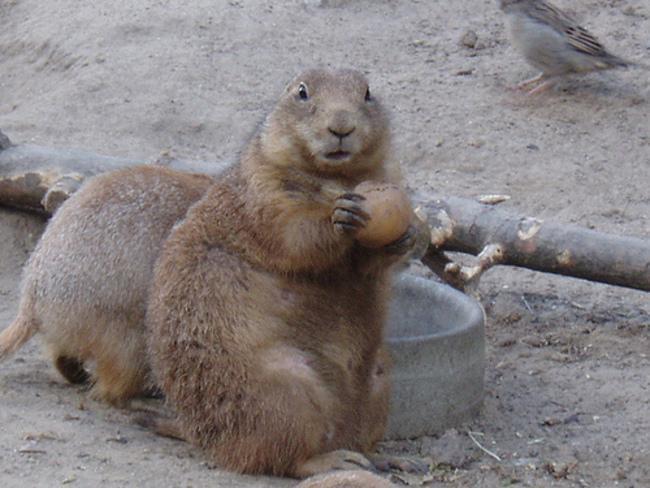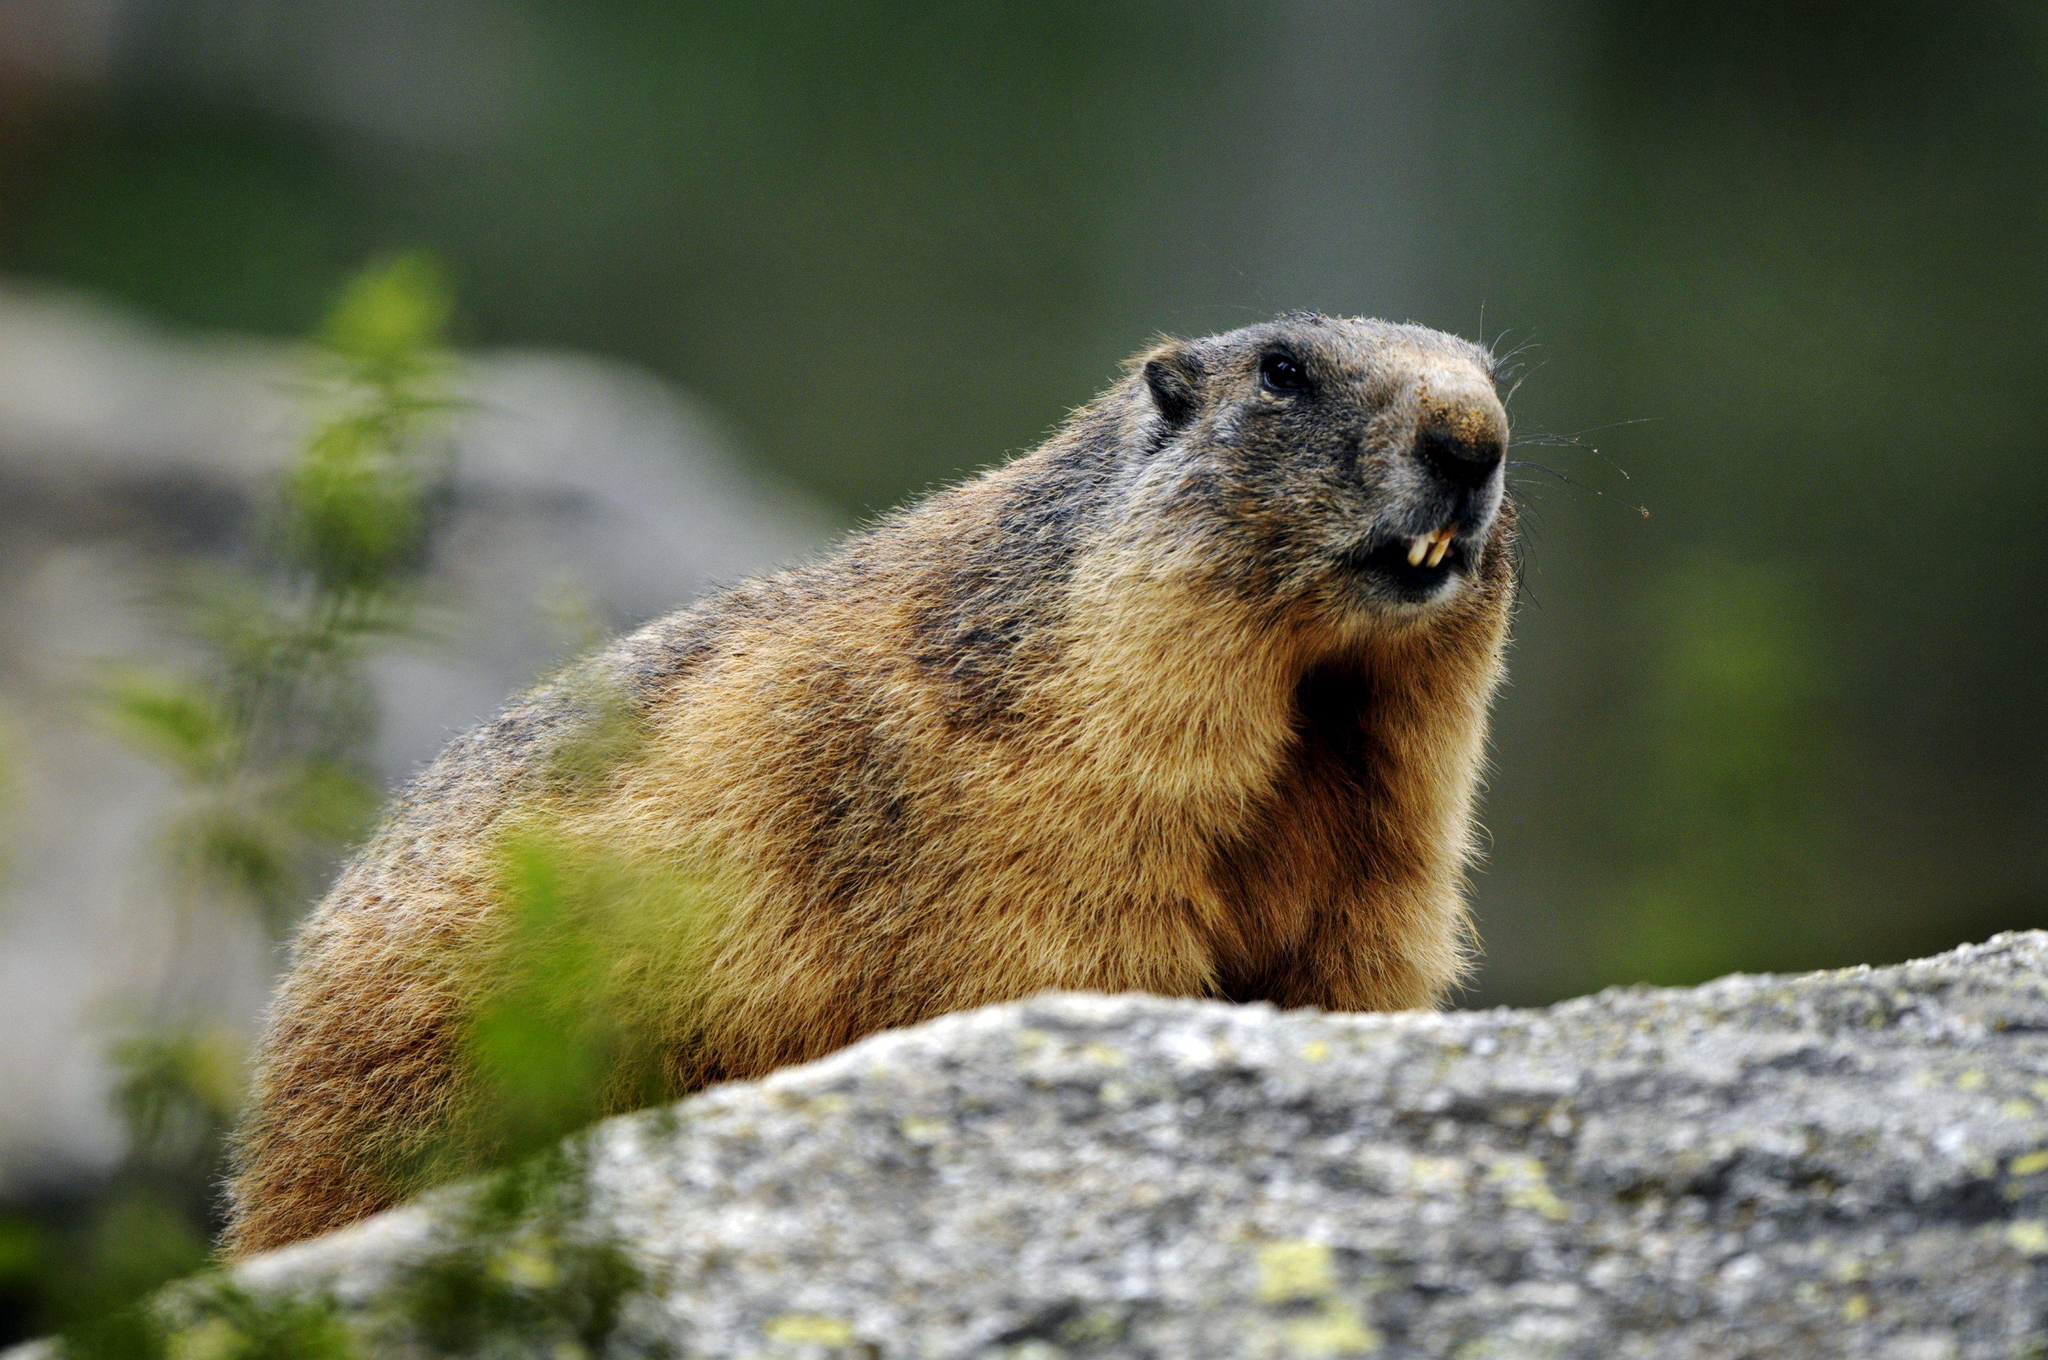The first image is the image on the left, the second image is the image on the right. Evaluate the accuracy of this statement regarding the images: "There are two animals total.". Is it true? Answer yes or no. No. The first image is the image on the left, the second image is the image on the right. Examine the images to the left and right. Is the description "Right image shows a non-upright marmot with lifted head facing rightward." accurate? Answer yes or no. Yes. 